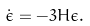<formula> <loc_0><loc_0><loc_500><loc_500>\dot { \epsilon } = - 3 H \epsilon .</formula> 